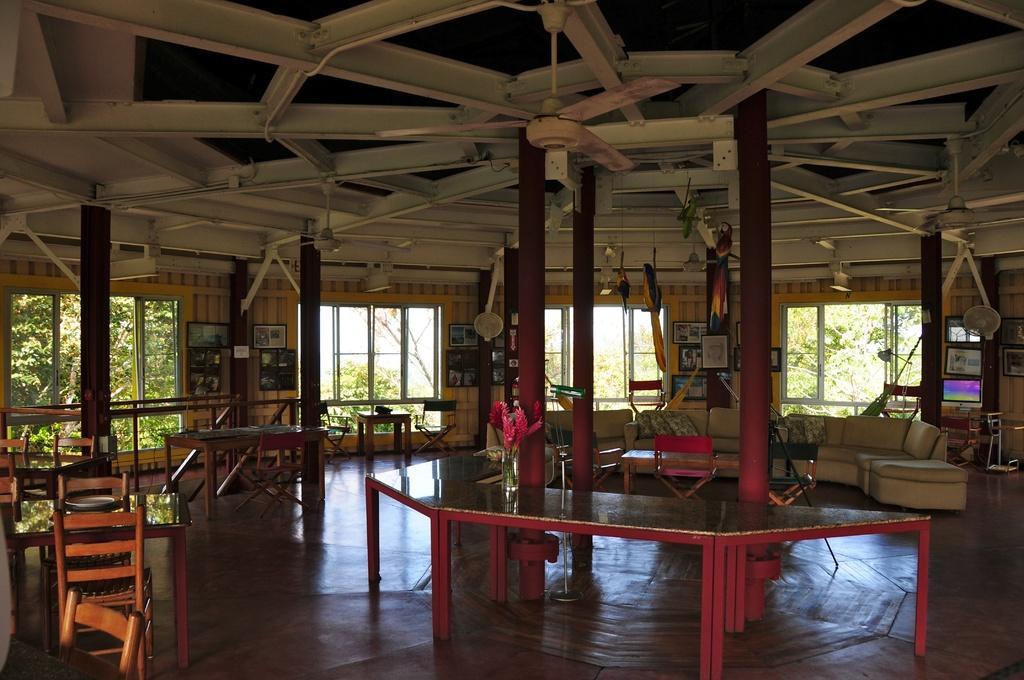Describe this image in one or two sentences. In the image there is sofa on the right side and the ceiling has fan, this picture seems to be clicked in a breakout area and there are tables chairs on the left side. 